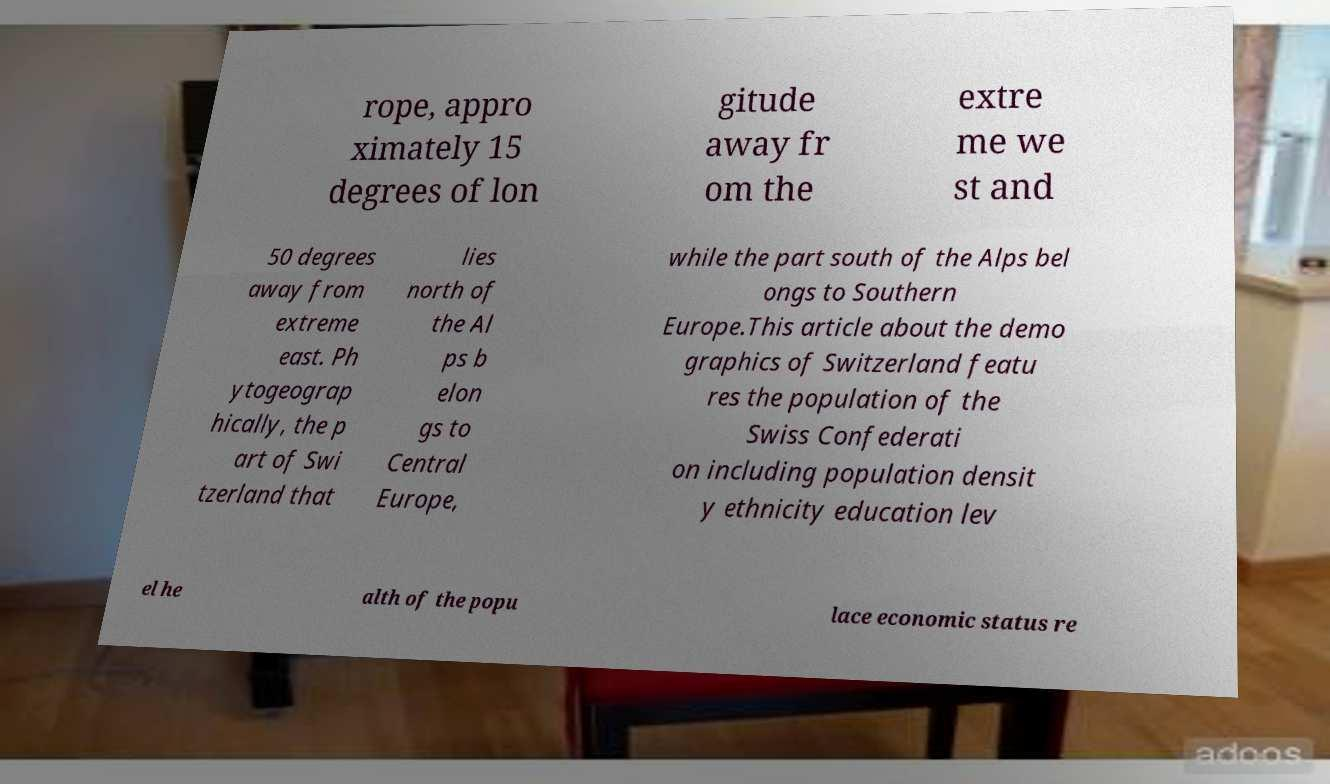What messages or text are displayed in this image? I need them in a readable, typed format. rope, appro ximately 15 degrees of lon gitude away fr om the extre me we st and 50 degrees away from extreme east. Ph ytogeograp hically, the p art of Swi tzerland that lies north of the Al ps b elon gs to Central Europe, while the part south of the Alps bel ongs to Southern Europe.This article about the demo graphics of Switzerland featu res the population of the Swiss Confederati on including population densit y ethnicity education lev el he alth of the popu lace economic status re 